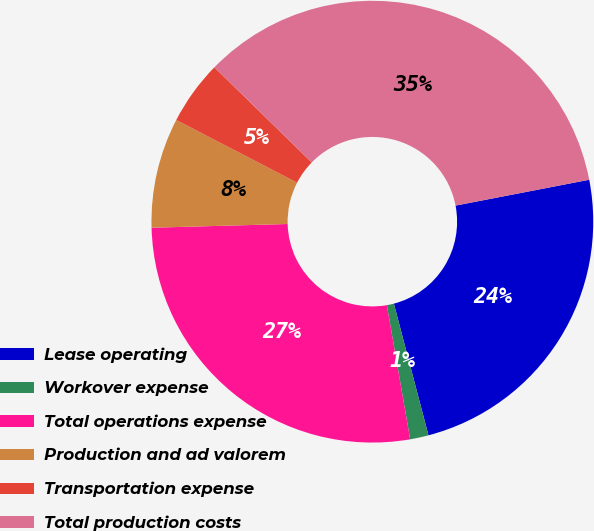<chart> <loc_0><loc_0><loc_500><loc_500><pie_chart><fcel>Lease operating<fcel>Workover expense<fcel>Total operations expense<fcel>Production and ad valorem<fcel>Transportation expense<fcel>Total production costs<nl><fcel>23.95%<fcel>1.35%<fcel>27.3%<fcel>8.05%<fcel>4.7%<fcel>34.64%<nl></chart> 